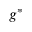Convert formula to latex. <formula><loc_0><loc_0><loc_500><loc_500>g ^ { * }</formula> 